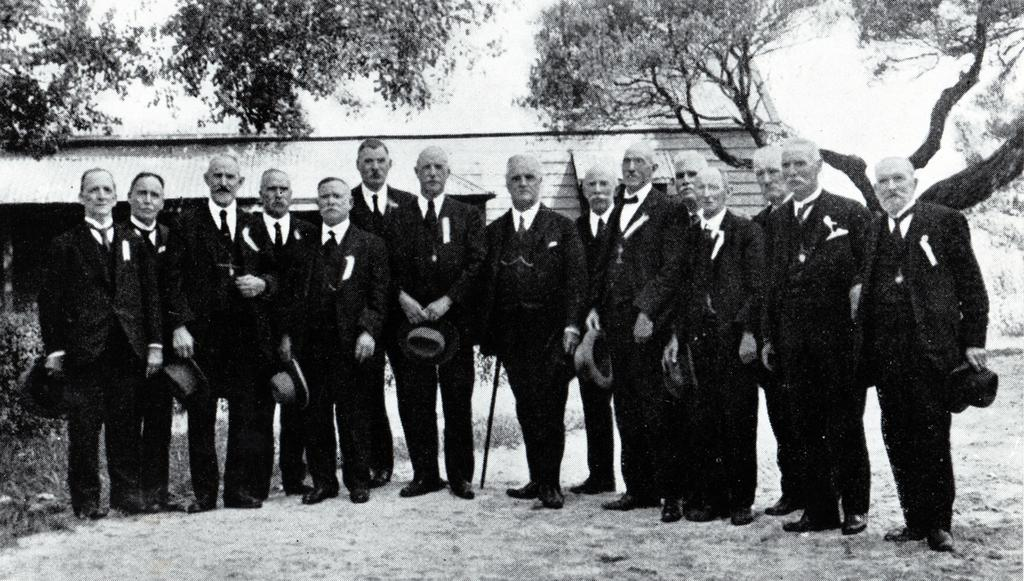How many people are in the image? There is a group of people standing in the image. What can be seen in the background of the image? There is a house, trees, and the sky visible in the background of the image. What is the color scheme of the image? The image is in black and white. What type of mark can be seen on the stem of the tree in the image? There is no mark on the stem of a tree in the image, as trees are not mentioned in the provided facts. 